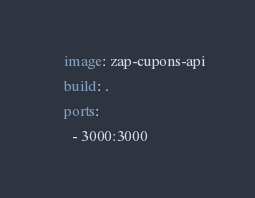<code> <loc_0><loc_0><loc_500><loc_500><_YAML_>    image: zap-cupons-api
    build: .
    ports:
      - 3000:3000</code> 